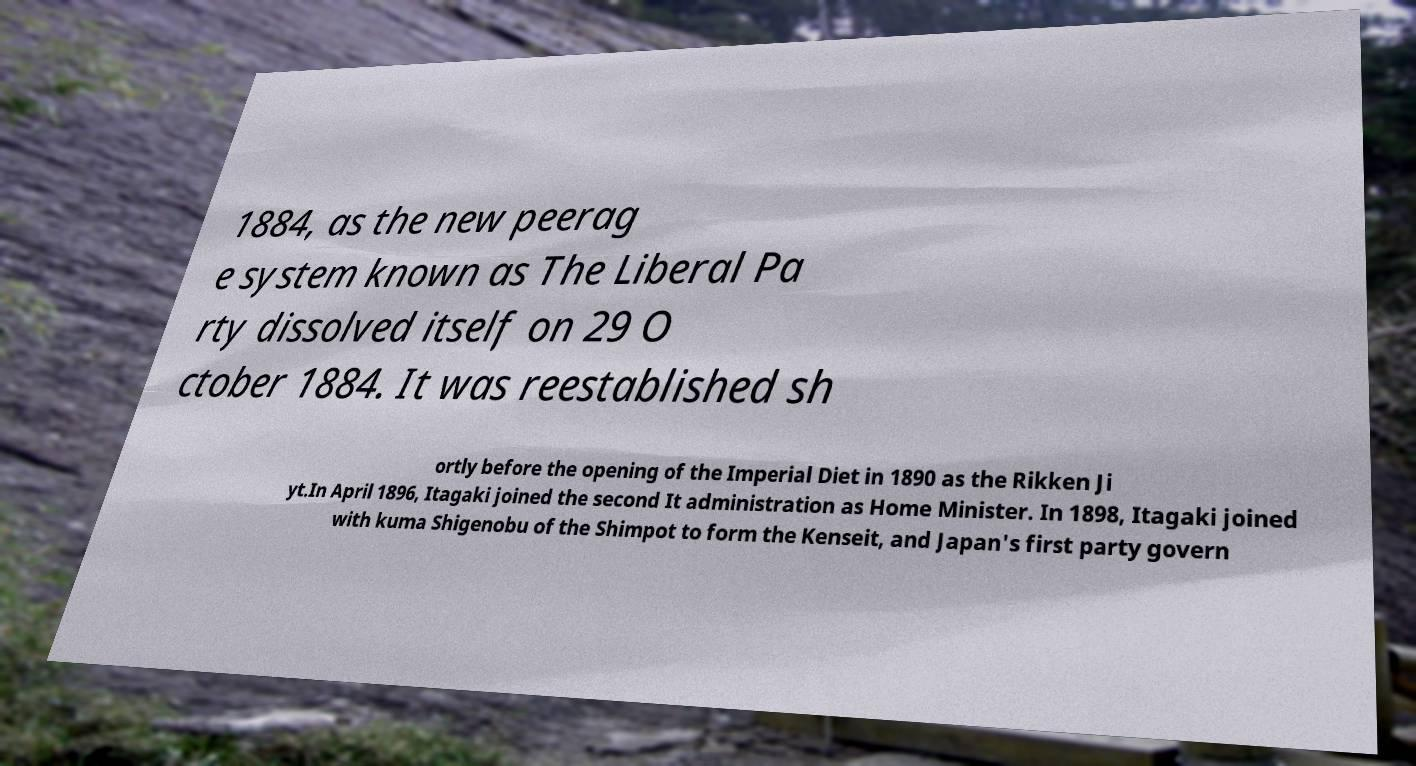For documentation purposes, I need the text within this image transcribed. Could you provide that? 1884, as the new peerag e system known as The Liberal Pa rty dissolved itself on 29 O ctober 1884. It was reestablished sh ortly before the opening of the Imperial Diet in 1890 as the Rikken Ji yt.In April 1896, Itagaki joined the second It administration as Home Minister. In 1898, Itagaki joined with kuma Shigenobu of the Shimpot to form the Kenseit, and Japan's first party govern 